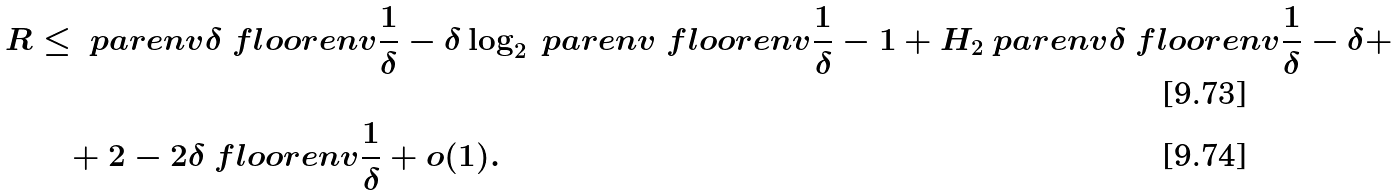<formula> <loc_0><loc_0><loc_500><loc_500>R & \leq \ p a r e n v { \delta \ f l o o r e n v { \frac { 1 } { \delta } } - \delta } \log _ { 2 } \ p a r e n v { \ f l o o r e n v { \frac { 1 } { \delta } } - 1 } + H _ { 2 } \ p a r e n v { \delta \ f l o o r e n v { \frac { 1 } { \delta } } - \delta } + \\ & \quad + 2 - 2 \delta \ f l o o r e n v { \frac { 1 } { \delta } } + o ( 1 ) .</formula> 